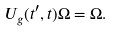Convert formula to latex. <formula><loc_0><loc_0><loc_500><loc_500>U _ { g } ( t ^ { \prime } , t ) \Omega = \Omega .</formula> 